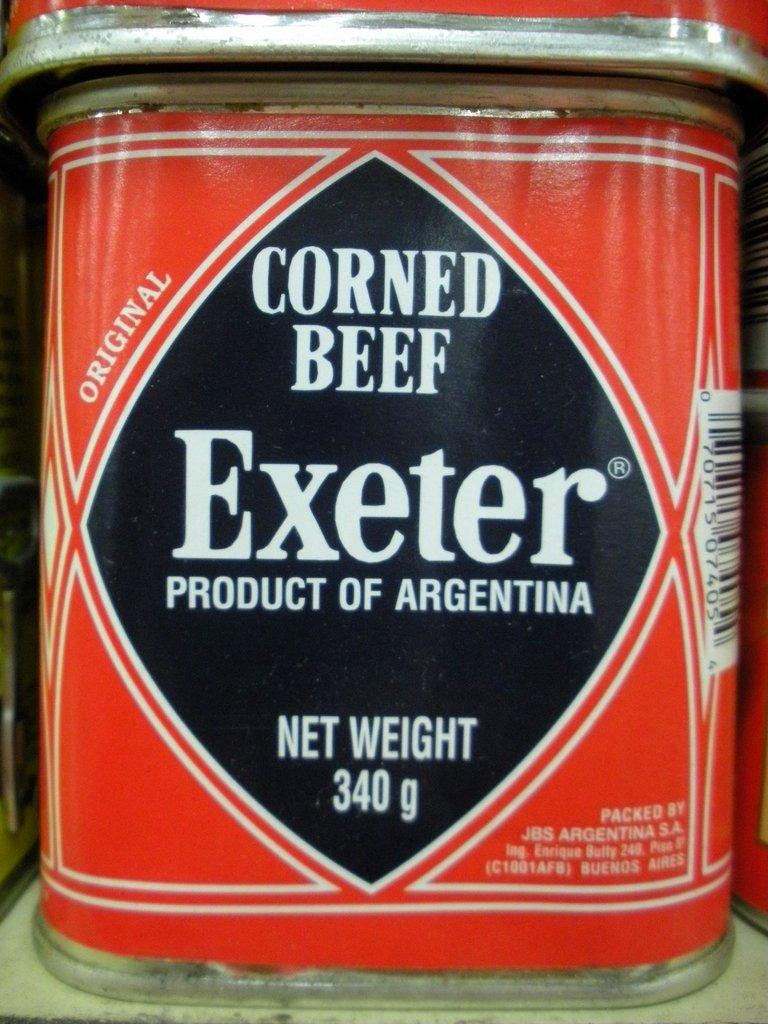Provide a one-sentence caption for the provided image. A 340 gram can of corned beef sits on the shelf. 